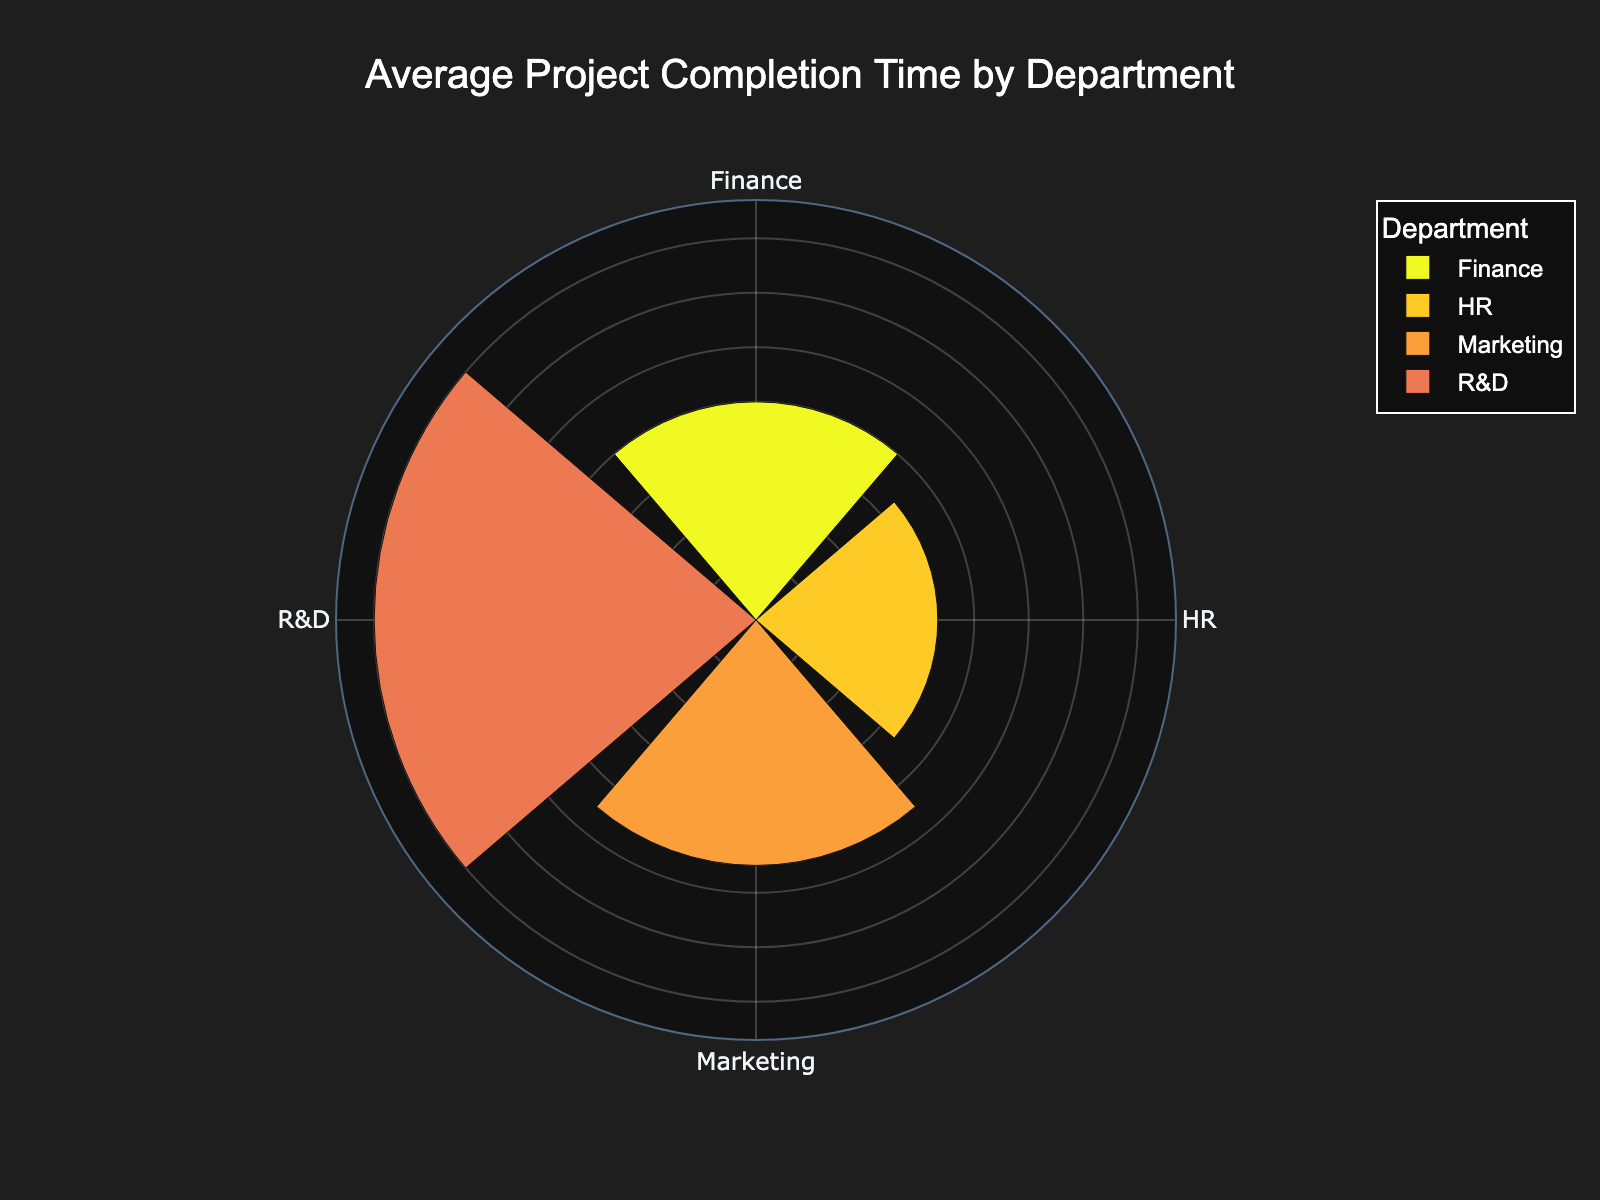What is the title of the chart? The title can be found at the top of the chart. It is usually prominently displayed.
Answer: Average Project Completion Time by Department How many departments are represented in the chart? The departments are labeled around the chart in a polar layout. Each section corresponds to a different department. Counting these labels gives the total number.
Answer: 4 Which department has the longest average project completion time? Look for the department with the longest bar (furthest from the center) in the polar chart. This represents the highest average completion time.
Answer: R&D Which department has the shortest average project completion time? Look for the department with the shortest bar (closest to the center) in the polar chart. This represents the shortest average completion time.
Answer: HR What is the average completion time for the Marketing department? The value for the Marketing department can be read directly from the corresponding section of the chart, often annotated or directly visible.
Answer: 9 weeks How does the average completion time of the HR department compare to that of the Finance department? Compare the lengths of the bars for HR and Finance. The difference or ratio will indicate which has a longer average completion time and by how much.
Answer: HR is shorter What is the difference in average project completion time between the R&D and Marketing departments? Find the completion times for both R&D and Marketing, then subtract the Marketing time from the R&D time.
Answer: 7 weeks Which two departments have the closest average completion times? Compare the bar lengths of each department to find the two with the most similar values.
Answer: Marketing and HR What is the combined average completion time for the HR and Finance departments? Add the average completion times for HR and Finance together to get the combined value.
Answer: 7.5 weeks 